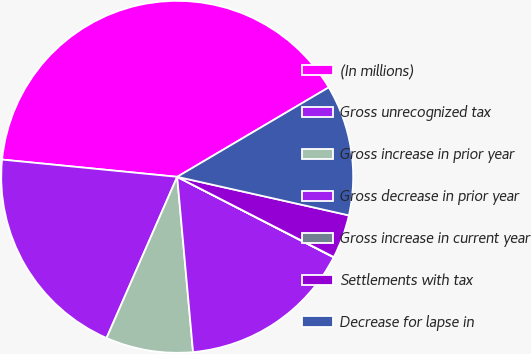Convert chart. <chart><loc_0><loc_0><loc_500><loc_500><pie_chart><fcel>(In millions)<fcel>Gross unrecognized tax<fcel>Gross increase in prior year<fcel>Gross decrease in prior year<fcel>Gross increase in current year<fcel>Settlements with tax<fcel>Decrease for lapse in<nl><fcel>39.95%<fcel>19.99%<fcel>8.01%<fcel>16.0%<fcel>0.03%<fcel>4.02%<fcel>12.0%<nl></chart> 